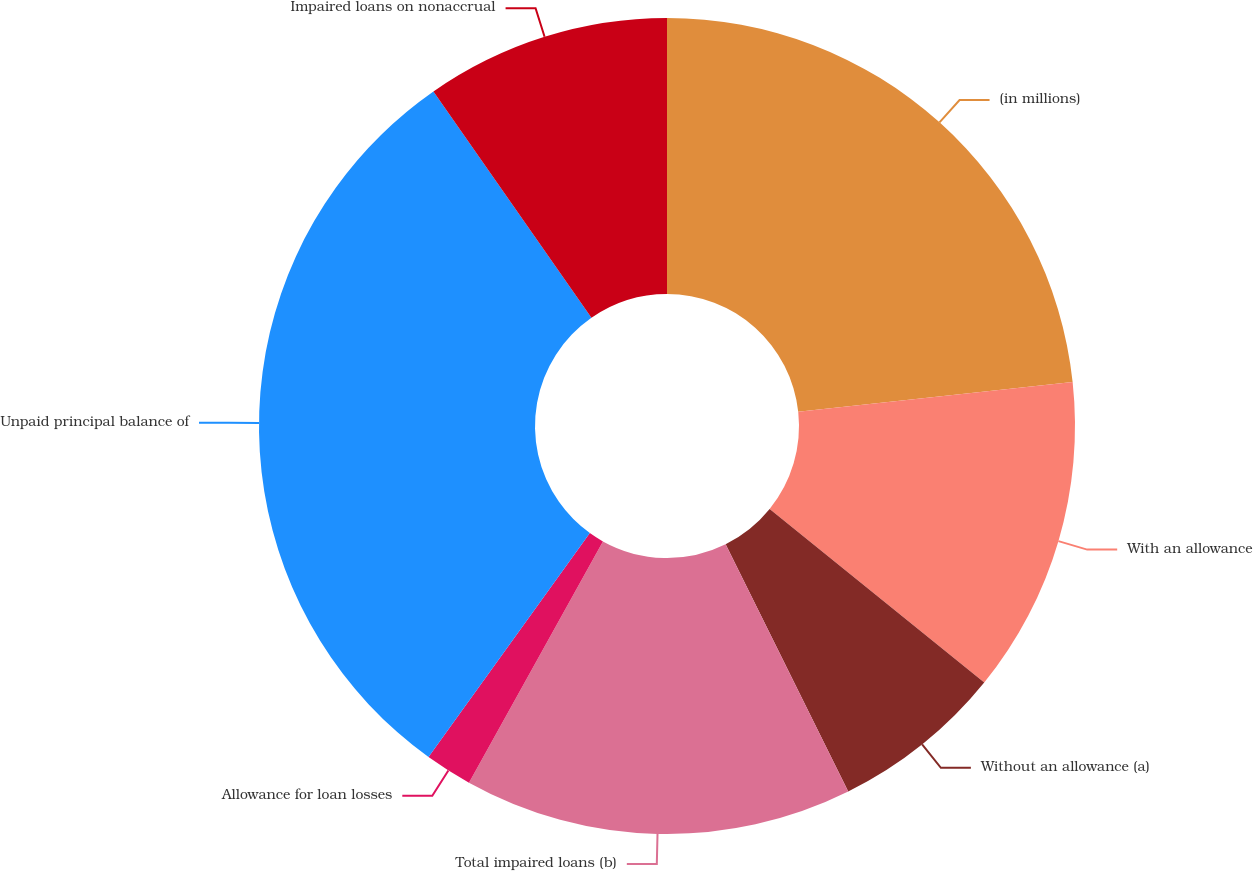<chart> <loc_0><loc_0><loc_500><loc_500><pie_chart><fcel>(in millions)<fcel>With an allowance<fcel>Without an allowance (a)<fcel>Total impaired loans (b)<fcel>Allowance for loan losses<fcel>Unpaid principal balance of<fcel>Impaired loans on nonaccrual<nl><fcel>23.28%<fcel>12.54%<fcel>6.85%<fcel>15.39%<fcel>1.87%<fcel>30.36%<fcel>9.7%<nl></chart> 